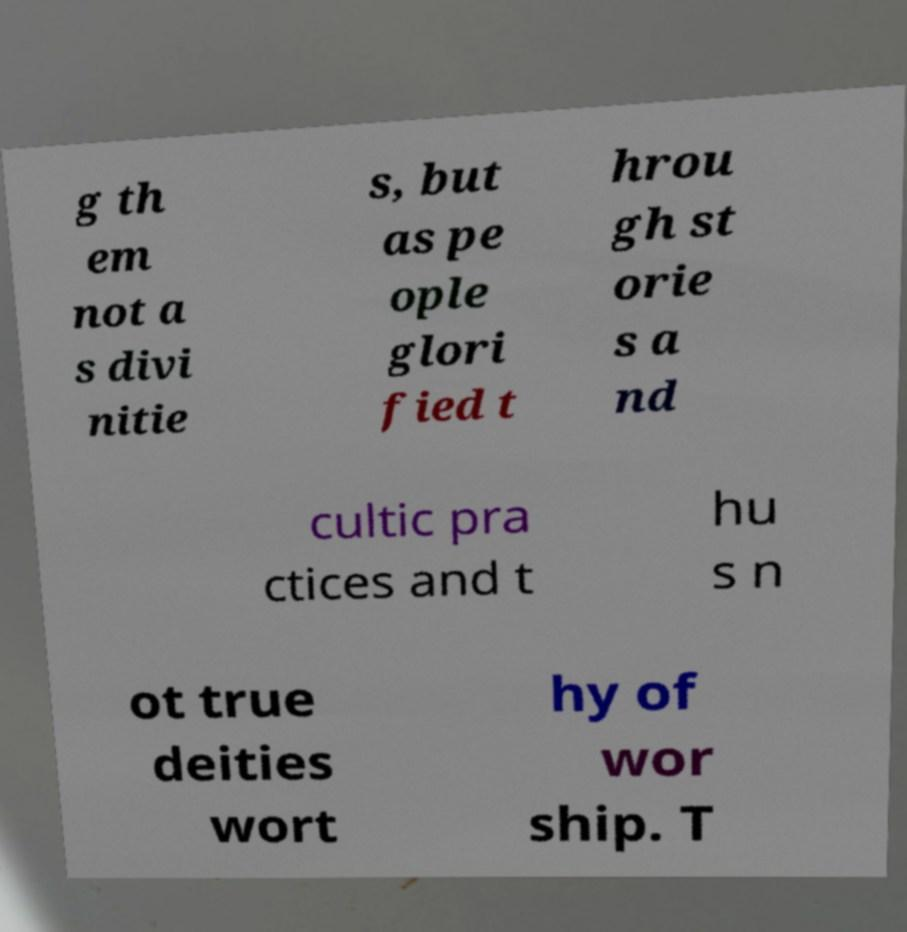I need the written content from this picture converted into text. Can you do that? g th em not a s divi nitie s, but as pe ople glori fied t hrou gh st orie s a nd cultic pra ctices and t hu s n ot true deities wort hy of wor ship. T 